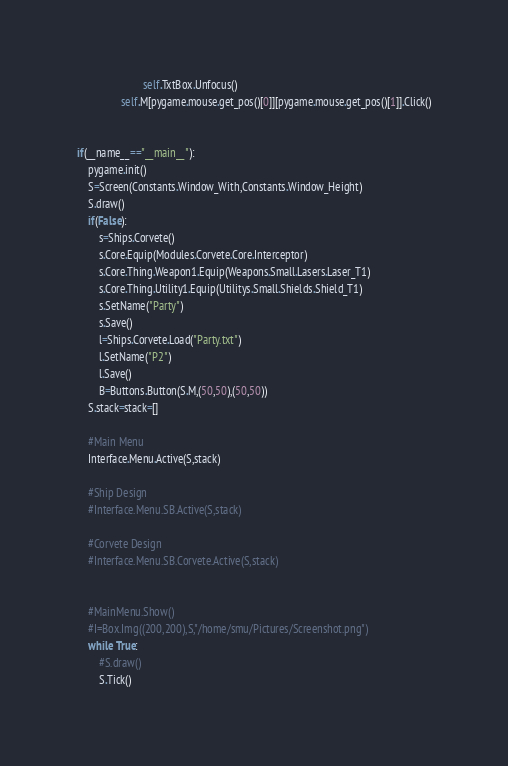Convert code to text. <code><loc_0><loc_0><loc_500><loc_500><_Python_>                        self.TxtBox.Unfocus()
                self.M[pygame.mouse.get_pos()[0]][pygame.mouse.get_pos()[1]].Click()


if(__name__=="__main__"):
    pygame.init()
    S=Screen(Constants.Window_With,Constants.Window_Height)
    S.draw()
    if(False):
        s=Ships.Corvete()
        s.Core.Equip(Modules.Corvete.Core.Interceptor)
        s.Core.Thing.Weapon1.Equip(Weapons.Small.Lasers.Laser_T1)
        s.Core.Thing.Utility1.Equip(Utilitys.Small.Shields.Shield_T1)
        s.SetName("Party")
        s.Save()
        l=Ships.Corvete.Load("Party.txt")
        l.SetName("P2")
        l.Save()
        B=Buttons.Button(S.M,(50,50),(50,50))
    S.stack=stack=[]

    #Main Menu
    Interface.Menu.Active(S,stack)

    #Ship Design
    #Interface.Menu.SB.Active(S,stack)

    #Corvete Design
    #Interface.Menu.SB.Corvete.Active(S,stack)


    #MainMenu.Show()
    #I=Box.Img((200,200),S,"/home/smu/Pictures/Screenshot.png")
    while True:
        #S.draw()
        S.Tick()
</code> 